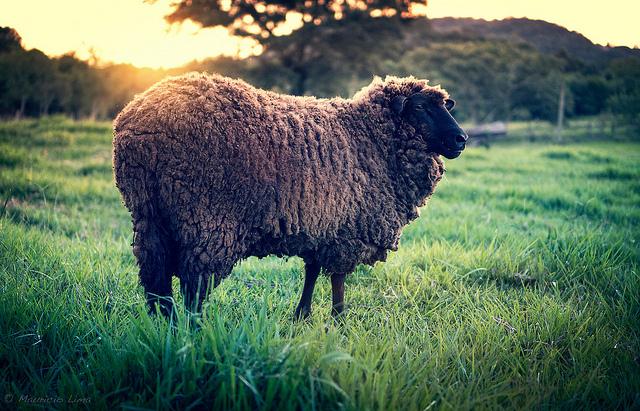Is the sun setting or rising?
Concise answer only. Setting. What kind of animal is this?
Short answer required. Sheep. What animal is this?
Concise answer only. Sheep. What color is the face of the sheep in the picture?
Quick response, please. Black. Is the grass tall or short?
Answer briefly. Tall. 